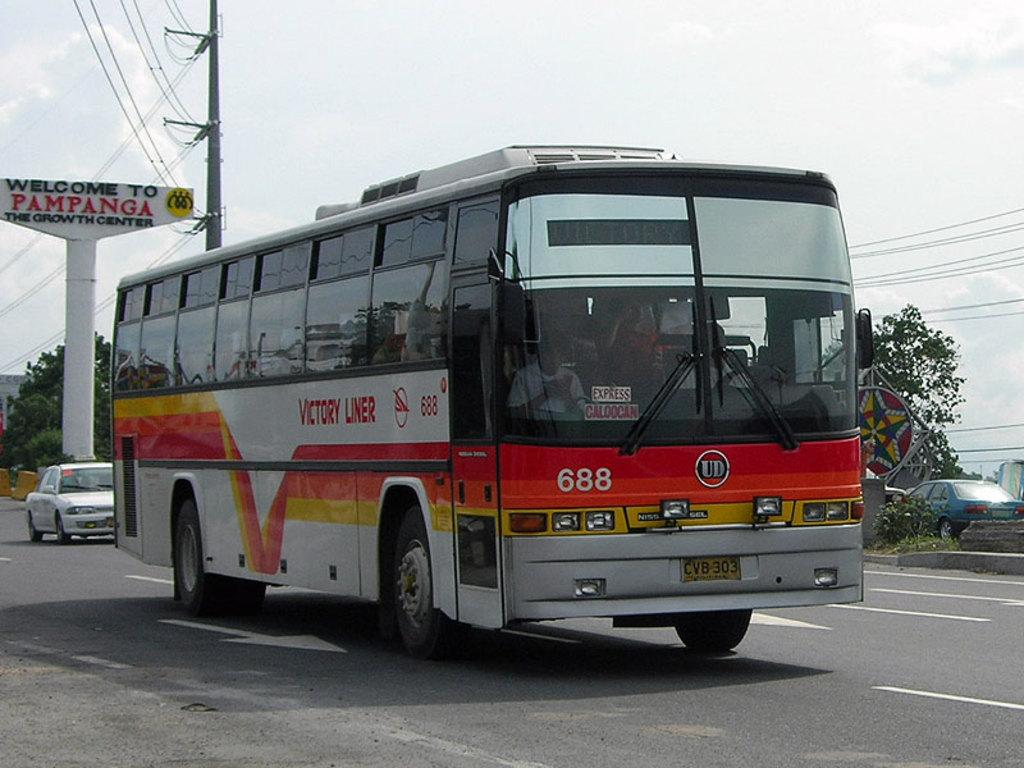What type of vehicle is in the image? There is a white and red color bus in the image. What is the bus doing in the image? The bus is moving on the road. What can be seen near the bus in the image? There is a street naming board in the image. What infrastructure elements are present in the image? Electric poles and cables are present in the image. What can be seen in the background of the image? There are trees visible in the background of the image. What type of throat problem is the bus driver experiencing in the image? There is no indication of any throat problems or the bus driver's well-being in the image. 